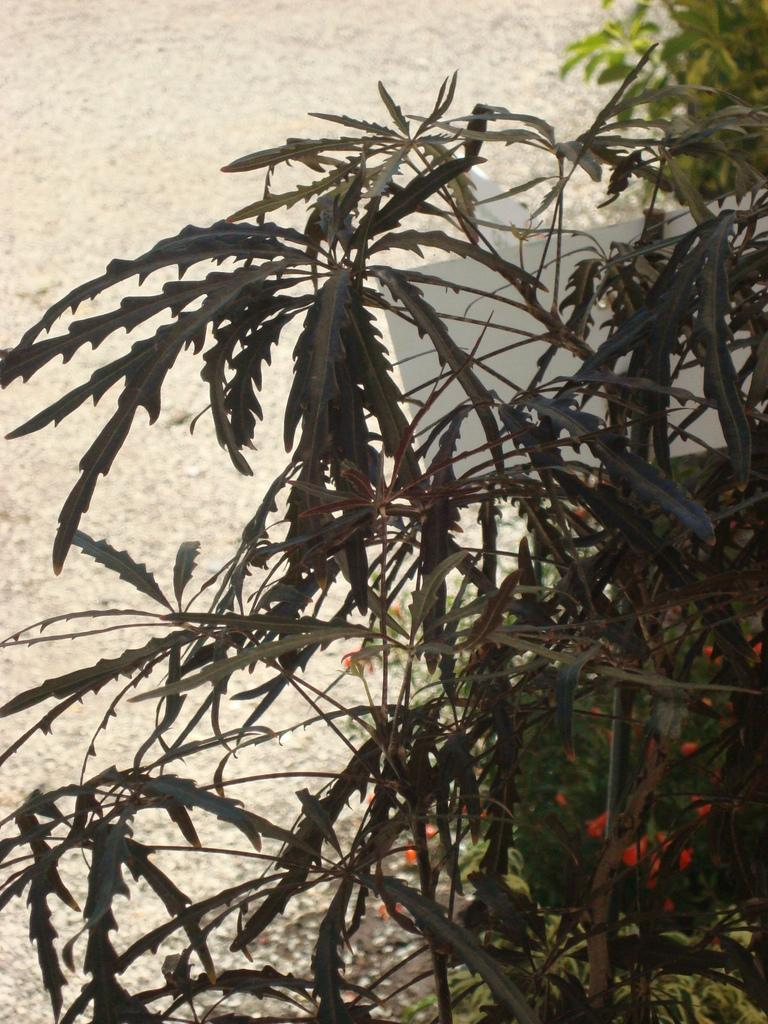What type of plants can be seen in the image? There are green color plants in the image. What type of gun is being used to shoot the leather board in the image? There is no gun, leather, or board present in the image; it only features green color plants. 